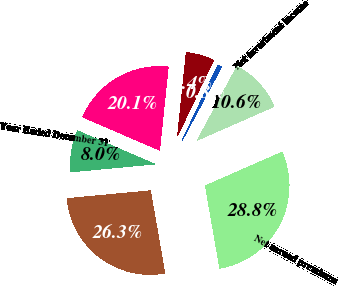Convert chart. <chart><loc_0><loc_0><loc_500><loc_500><pie_chart><fcel>Year Ended December 31<fcel>Net written premiums<fcel>Net earned premiums<fcel>Net investment income<fcel>Incurred claim and claim<fcel>Amortization of deferred<fcel>Paid claim and claim<nl><fcel>7.99%<fcel>26.26%<fcel>28.84%<fcel>10.57%<fcel>0.78%<fcel>5.41%<fcel>20.15%<nl></chart> 